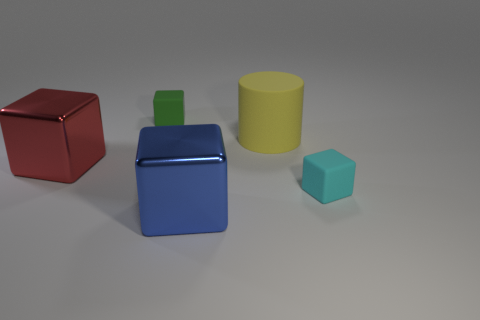Do the red thing and the blue metallic block have the same size?
Provide a short and direct response. Yes. Is the number of rubber things behind the small green rubber block less than the number of big objects that are behind the blue shiny thing?
Keep it short and to the point. Yes. How big is the matte cylinder?
Your answer should be very brief. Large. How many big things are either green matte things or green metal objects?
Make the answer very short. 0. Do the cyan matte cube and the yellow matte thing that is in front of the small green matte cube have the same size?
Your answer should be very brief. No. Is there any other thing that is the same shape as the big yellow thing?
Provide a succinct answer. No. How many cylinders are there?
Provide a short and direct response. 1. How many brown things are matte objects or big matte objects?
Provide a short and direct response. 0. Is the small block that is left of the blue cube made of the same material as the tiny cyan cube?
Ensure brevity in your answer.  Yes. How many other objects are there of the same material as the cylinder?
Your answer should be very brief. 2. 